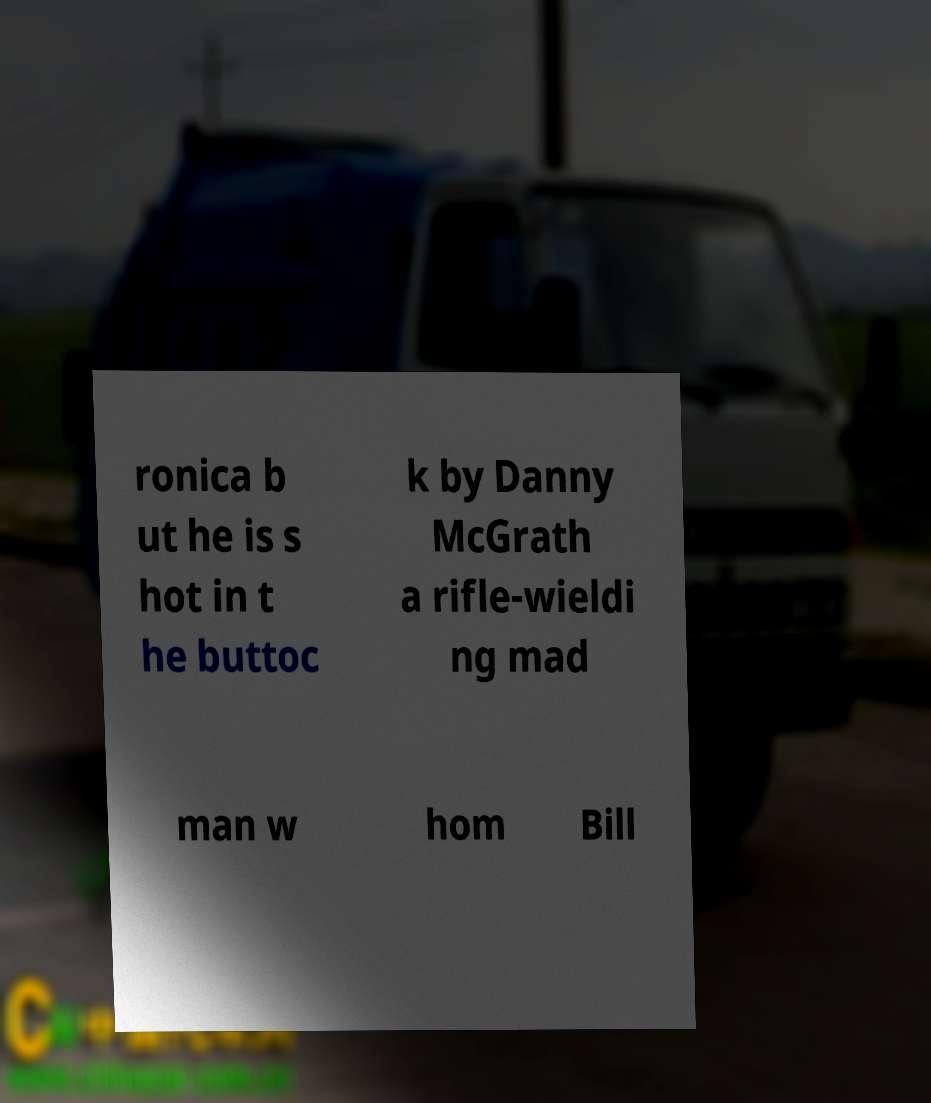Can you accurately transcribe the text from the provided image for me? ronica b ut he is s hot in t he buttoc k by Danny McGrath a rifle-wieldi ng mad man w hom Bill 